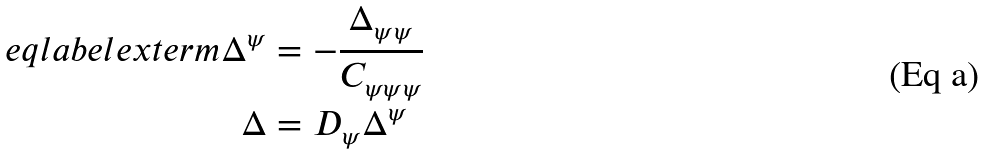Convert formula to latex. <formula><loc_0><loc_0><loc_500><loc_500>\ e q l a b e l { e x t e r m } \Delta ^ { \psi } & = - \frac { \Delta _ { \psi \psi } } { C _ { \psi \psi \psi } } \\ \Delta & = D _ { \psi } \Delta ^ { \psi }</formula> 